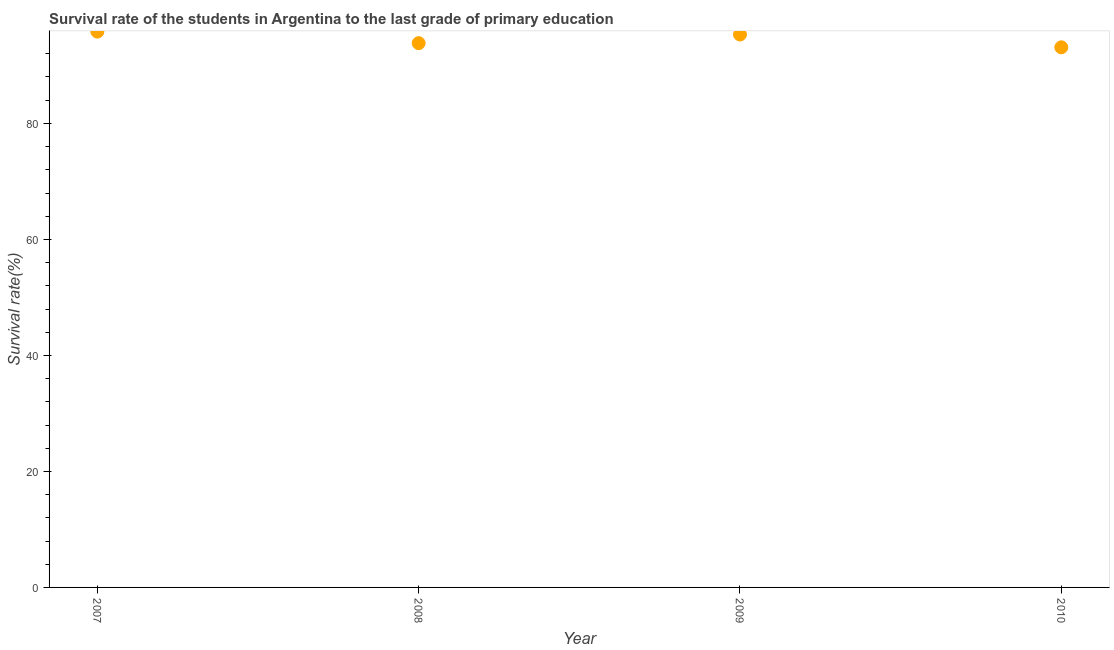What is the survival rate in primary education in 2007?
Offer a very short reply. 95.82. Across all years, what is the maximum survival rate in primary education?
Provide a succinct answer. 95.82. Across all years, what is the minimum survival rate in primary education?
Make the answer very short. 93.12. In which year was the survival rate in primary education minimum?
Your response must be concise. 2010. What is the sum of the survival rate in primary education?
Offer a very short reply. 378.1. What is the difference between the survival rate in primary education in 2007 and 2010?
Your response must be concise. 2.71. What is the average survival rate in primary education per year?
Your answer should be compact. 94.53. What is the median survival rate in primary education?
Your response must be concise. 94.58. In how many years, is the survival rate in primary education greater than 84 %?
Provide a short and direct response. 4. What is the ratio of the survival rate in primary education in 2008 to that in 2009?
Ensure brevity in your answer.  0.98. Is the survival rate in primary education in 2007 less than that in 2008?
Offer a very short reply. No. What is the difference between the highest and the second highest survival rate in primary education?
Offer a very short reply. 0.5. What is the difference between the highest and the lowest survival rate in primary education?
Give a very brief answer. 2.71. Are the values on the major ticks of Y-axis written in scientific E-notation?
Give a very brief answer. No. Does the graph contain any zero values?
Your response must be concise. No. Does the graph contain grids?
Your answer should be compact. No. What is the title of the graph?
Your answer should be compact. Survival rate of the students in Argentina to the last grade of primary education. What is the label or title of the X-axis?
Your response must be concise. Year. What is the label or title of the Y-axis?
Provide a succinct answer. Survival rate(%). What is the Survival rate(%) in 2007?
Your answer should be very brief. 95.82. What is the Survival rate(%) in 2008?
Offer a terse response. 93.84. What is the Survival rate(%) in 2009?
Your answer should be very brief. 95.32. What is the Survival rate(%) in 2010?
Provide a short and direct response. 93.12. What is the difference between the Survival rate(%) in 2007 and 2008?
Your answer should be very brief. 1.99. What is the difference between the Survival rate(%) in 2007 and 2009?
Ensure brevity in your answer.  0.5. What is the difference between the Survival rate(%) in 2007 and 2010?
Offer a terse response. 2.71. What is the difference between the Survival rate(%) in 2008 and 2009?
Ensure brevity in your answer.  -1.49. What is the difference between the Survival rate(%) in 2008 and 2010?
Offer a very short reply. 0.72. What is the difference between the Survival rate(%) in 2009 and 2010?
Your answer should be compact. 2.21. What is the ratio of the Survival rate(%) in 2007 to that in 2009?
Your response must be concise. 1. What is the ratio of the Survival rate(%) in 2007 to that in 2010?
Give a very brief answer. 1.03. What is the ratio of the Survival rate(%) in 2008 to that in 2009?
Give a very brief answer. 0.98. What is the ratio of the Survival rate(%) in 2008 to that in 2010?
Offer a very short reply. 1.01. 